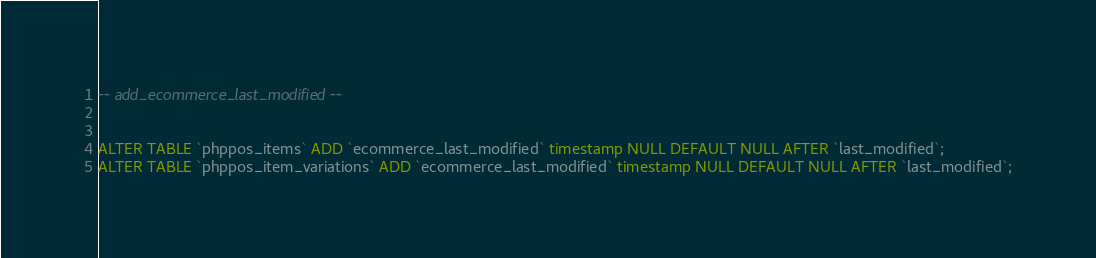Convert code to text. <code><loc_0><loc_0><loc_500><loc_500><_SQL_>-- add_ecommerce_last_modified --


ALTER TABLE `phppos_items` ADD `ecommerce_last_modified` timestamp NULL DEFAULT NULL AFTER `last_modified`;
ALTER TABLE `phppos_item_variations` ADD `ecommerce_last_modified` timestamp NULL DEFAULT NULL AFTER `last_modified`;</code> 